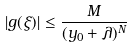Convert formula to latex. <formula><loc_0><loc_0><loc_500><loc_500>| g ( \xi ) | \leq \frac { M } { ( y _ { 0 } + \lambda ) ^ { N } }</formula> 